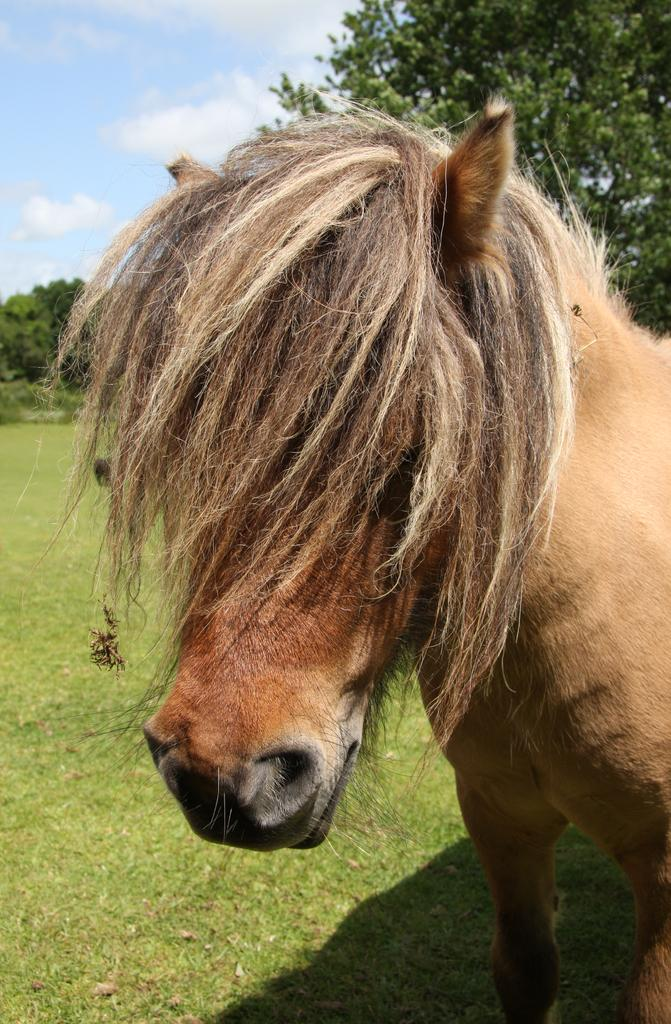What type of animal is in the image? There is a pony horse in the image. What is the pony horse doing? The pony horse is standing. What type of vegetation is visible in the image? There is grass in the image. What else can be seen in the image besides the pony horse and grass? There are trees and the sky visible in the image. What is the condition of the sky in the image? The sky is visible in the image, and there are clouds present. How far away is the parent of the pony horse in the image? There is no parent of the pony horse visible in the image, and therefore no distance can be determined. 